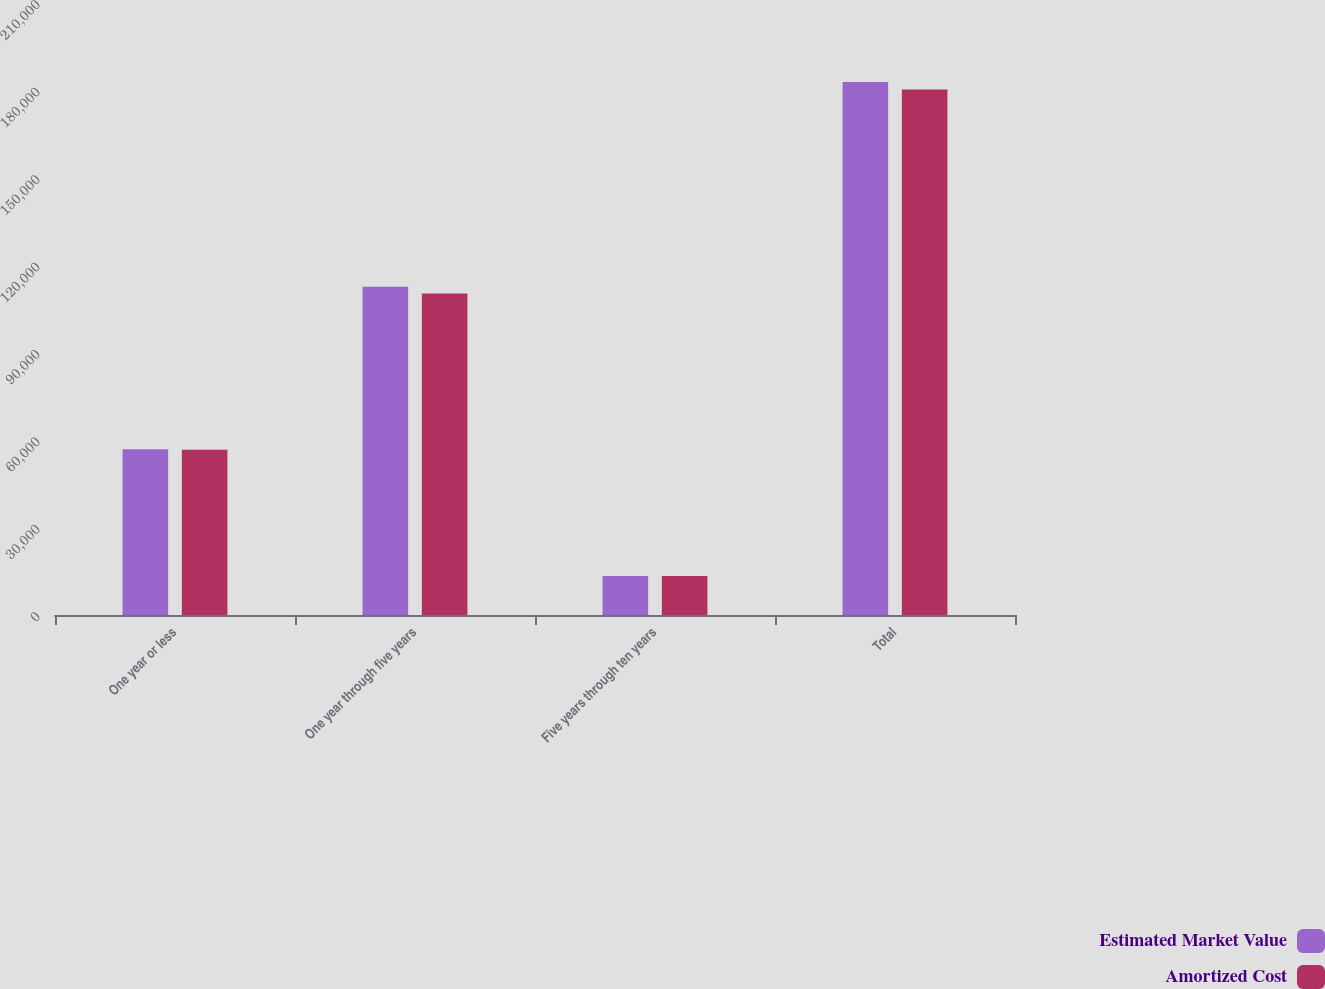Convert chart to OTSL. <chart><loc_0><loc_0><loc_500><loc_500><stacked_bar_chart><ecel><fcel>One year or less<fcel>One year through five years<fcel>Five years through ten years<fcel>Total<nl><fcel>Estimated Market Value<fcel>56863<fcel>112623<fcel>13416<fcel>182902<nl><fcel>Amortized Cost<fcel>56700<fcel>110311<fcel>13350<fcel>180361<nl></chart> 